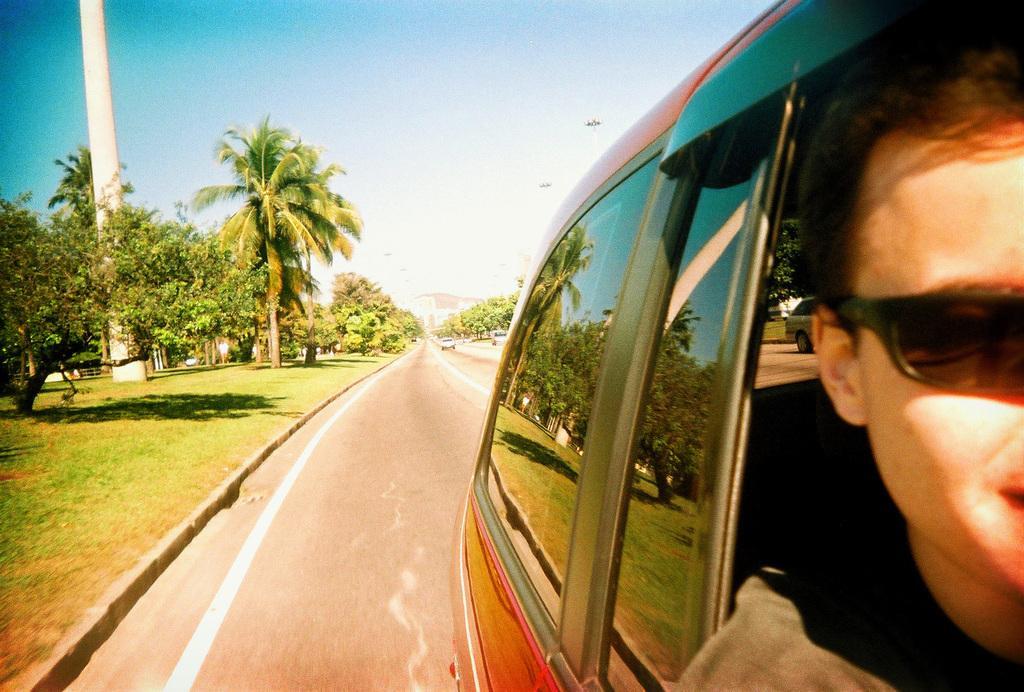Describe this image in one or two sentences. In this picture we can see a person in a vehicle. Behind the vehicle, there are two other vehicles on the road. On the right side of the road, there is a pole, trees and grass. Behind the trees, there is the sky. 